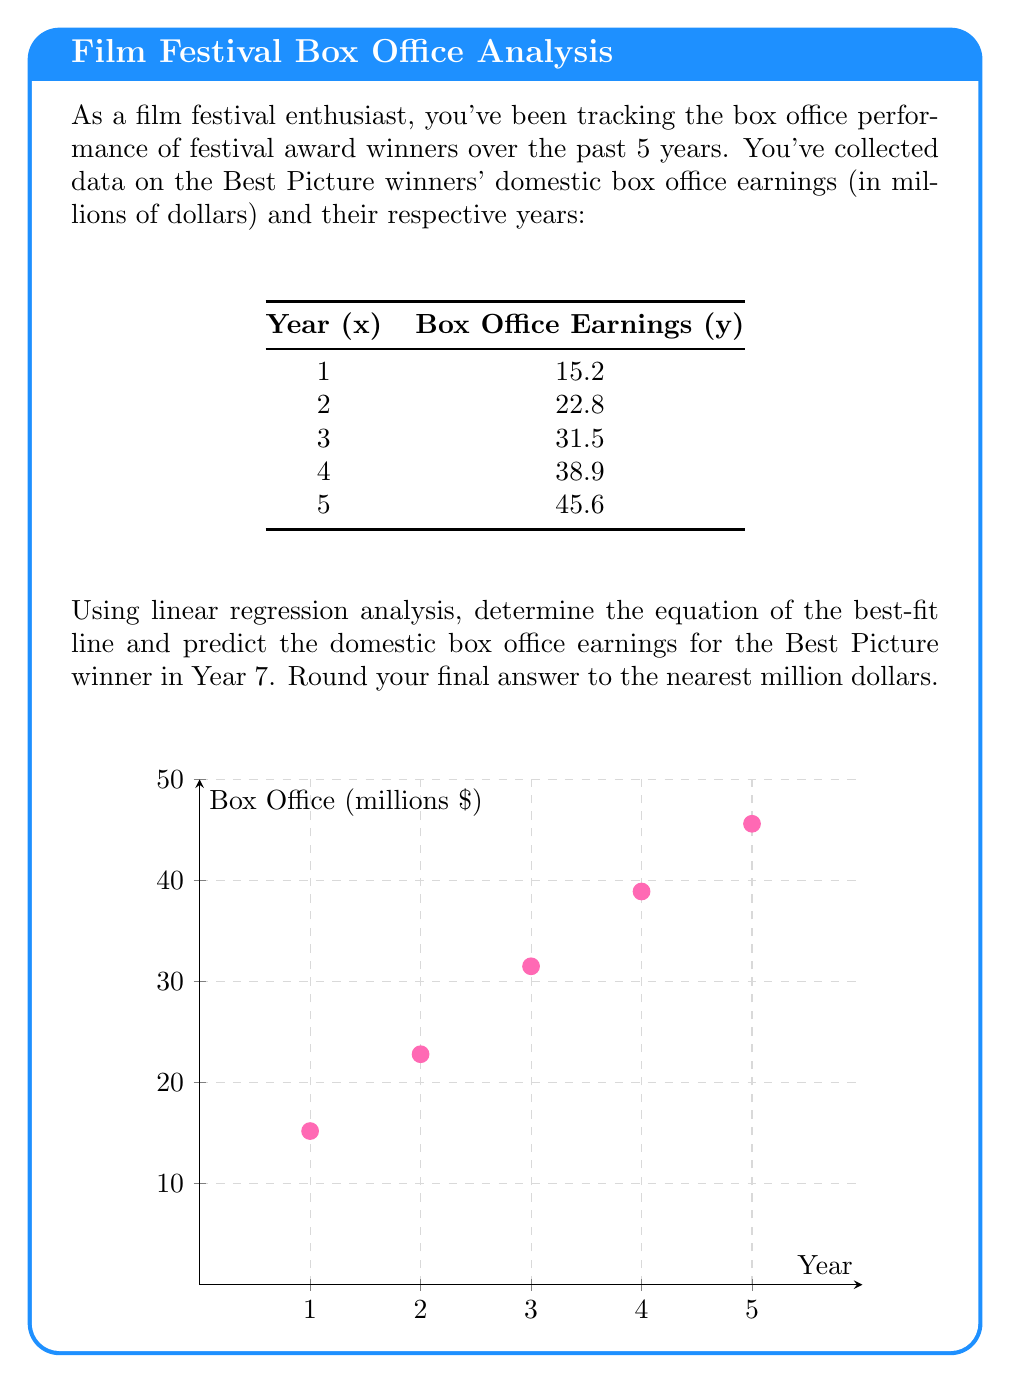Help me with this question. To solve this problem using linear regression, we'll follow these steps:

1) First, we need to calculate the following sums:
   $\sum x = 1 + 2 + 3 + 4 + 5 = 15$
   $\sum y = 15.2 + 22.8 + 31.5 + 38.9 + 45.6 = 154$
   $\sum xy = (1)(15.2) + (2)(22.8) + (3)(31.5) + (4)(38.9) + (5)(45.6) = 566$
   $\sum x^2 = 1^2 + 2^2 + 3^2 + 4^2 + 5^2 = 55$
   $n = 5$ (number of data points)

2) Now we can calculate the slope (m) and y-intercept (b) of the best-fit line:

   $m = \frac{n\sum xy - \sum x \sum y}{n\sum x^2 - (\sum x)^2}$
   $m = \frac{5(566) - (15)(154)}{5(55) - (15)^2} = \frac{2830 - 2310}{275 - 225} = \frac{520}{50} = 10.4$

   $b = \frac{\sum y - m\sum x}{n} = \frac{154 - 10.4(15)}{5} = \frac{154 - 156}{5} = -0.4$

3) The equation of the best-fit line is:
   $y = 10.4x - 0.4$

4) To predict the box office earnings for Year 7, we substitute x = 7 into our equation:
   $y = 10.4(7) - 0.4 = 72.8 - 0.4 = 72.4$

5) Rounding to the nearest million dollars, we get 72 million dollars.
Answer: $72 million 